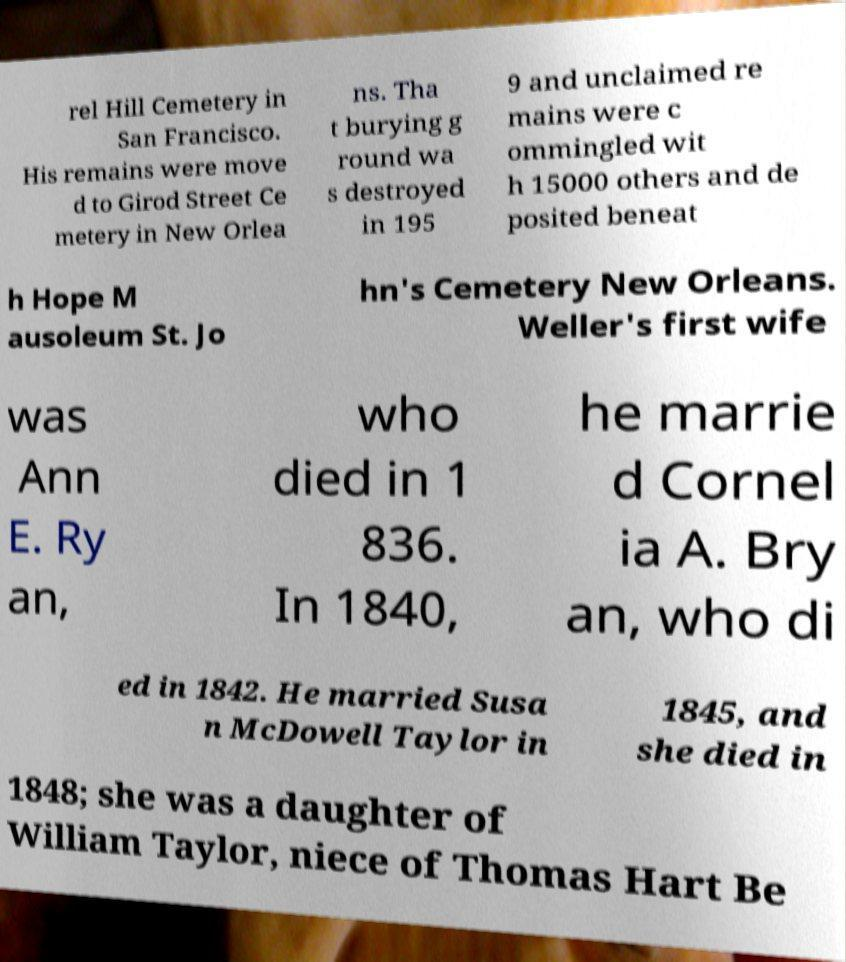Can you accurately transcribe the text from the provided image for me? rel Hill Cemetery in San Francisco. His remains were move d to Girod Street Ce metery in New Orlea ns. Tha t burying g round wa s destroyed in 195 9 and unclaimed re mains were c ommingled wit h 15000 others and de posited beneat h Hope M ausoleum St. Jo hn's Cemetery New Orleans. Weller's first wife was Ann E. Ry an, who died in 1 836. In 1840, he marrie d Cornel ia A. Bry an, who di ed in 1842. He married Susa n McDowell Taylor in 1845, and she died in 1848; she was a daughter of William Taylor, niece of Thomas Hart Be 